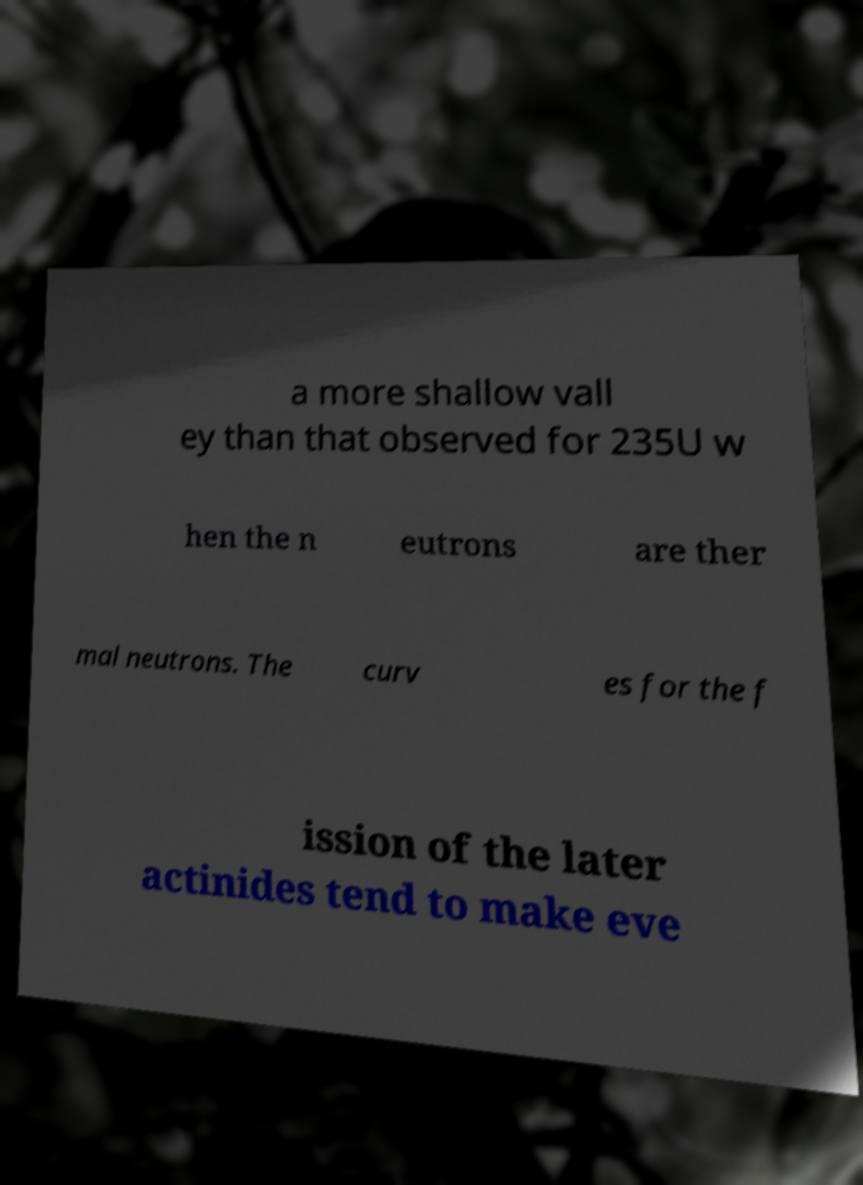Please identify and transcribe the text found in this image. a more shallow vall ey than that observed for 235U w hen the n eutrons are ther mal neutrons. The curv es for the f ission of the later actinides tend to make eve 